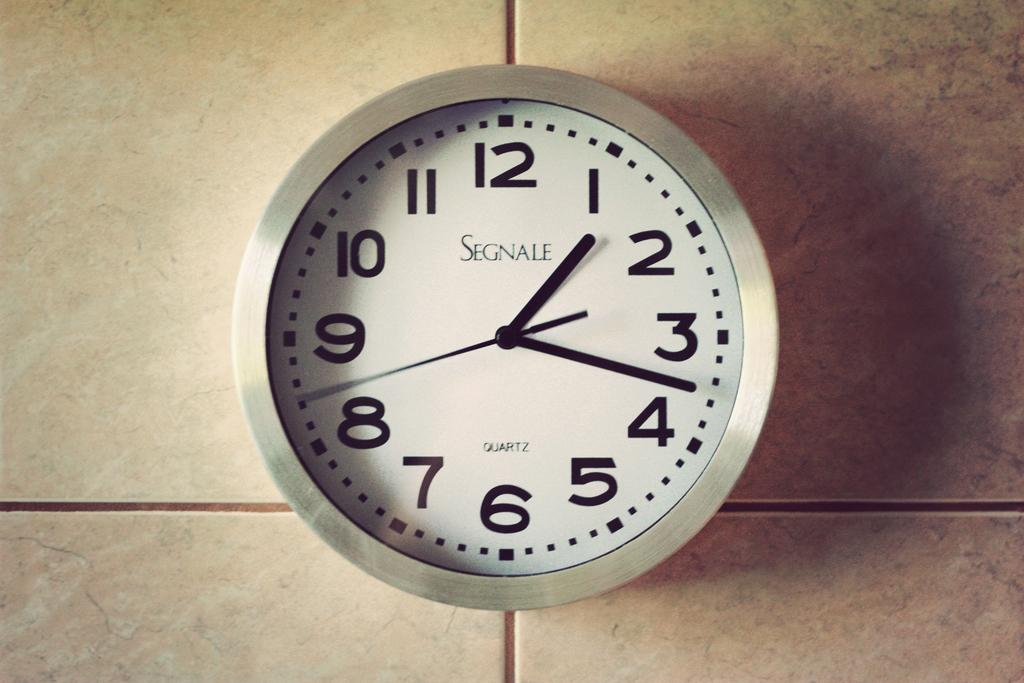<image>
Present a compact description of the photo's key features. The Segnale clock on the wall shows that the time is 1:18. 